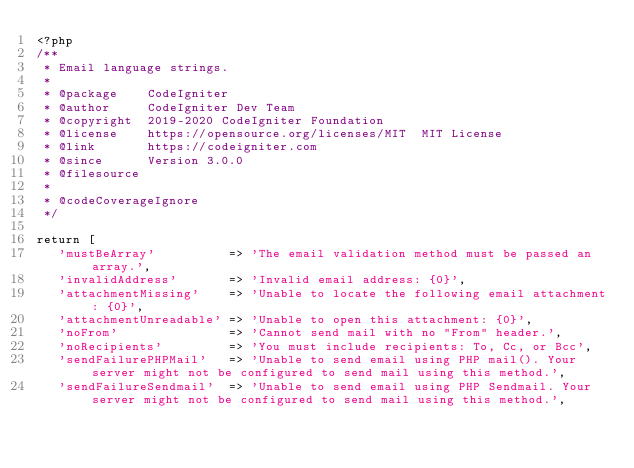Convert code to text. <code><loc_0><loc_0><loc_500><loc_500><_PHP_><?php
/**
 * Email language strings.
 *
 * @package    CodeIgniter
 * @author     CodeIgniter Dev Team
 * @copyright  2019-2020 CodeIgniter Foundation
 * @license    https://opensource.org/licenses/MIT	MIT License
 * @link       https://codeigniter.com
 * @since      Version 3.0.0
 * @filesource
 *
 * @codeCoverageIgnore
 */

return [
   'mustBeArray'          => 'The email validation method must be passed an array.',
   'invalidAddress'       => 'Invalid email address: {0}',
   'attachmentMissing'    => 'Unable to locate the following email attachment: {0}',
   'attachmentUnreadable' => 'Unable to open this attachment: {0}',
   'noFrom'               => 'Cannot send mail with no "From" header.',
   'noRecipients'         => 'You must include recipients: To, Cc, or Bcc',
   'sendFailurePHPMail'   => 'Unable to send email using PHP mail(). Your server might not be configured to send mail using this method.',
   'sendFailureSendmail'  => 'Unable to send email using PHP Sendmail. Your server might not be configured to send mail using this method.',</code> 